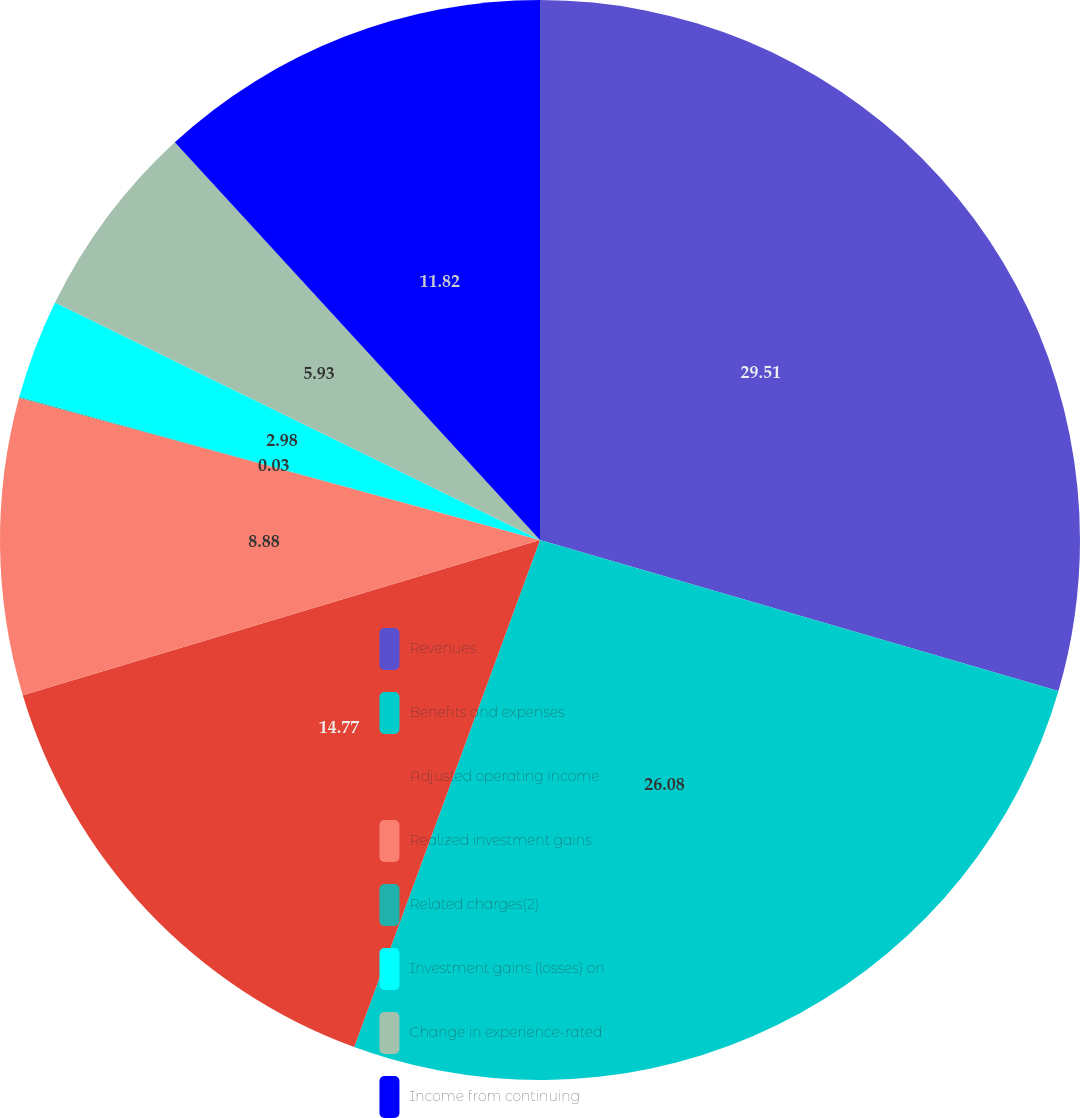Convert chart. <chart><loc_0><loc_0><loc_500><loc_500><pie_chart><fcel>Revenues<fcel>Benefits and expenses<fcel>Adjusted operating income<fcel>Realized investment gains<fcel>Related charges(2)<fcel>Investment gains (losses) on<fcel>Change in experience-rated<fcel>Income from continuing<nl><fcel>29.51%<fcel>26.08%<fcel>14.77%<fcel>8.88%<fcel>0.03%<fcel>2.98%<fcel>5.93%<fcel>11.82%<nl></chart> 